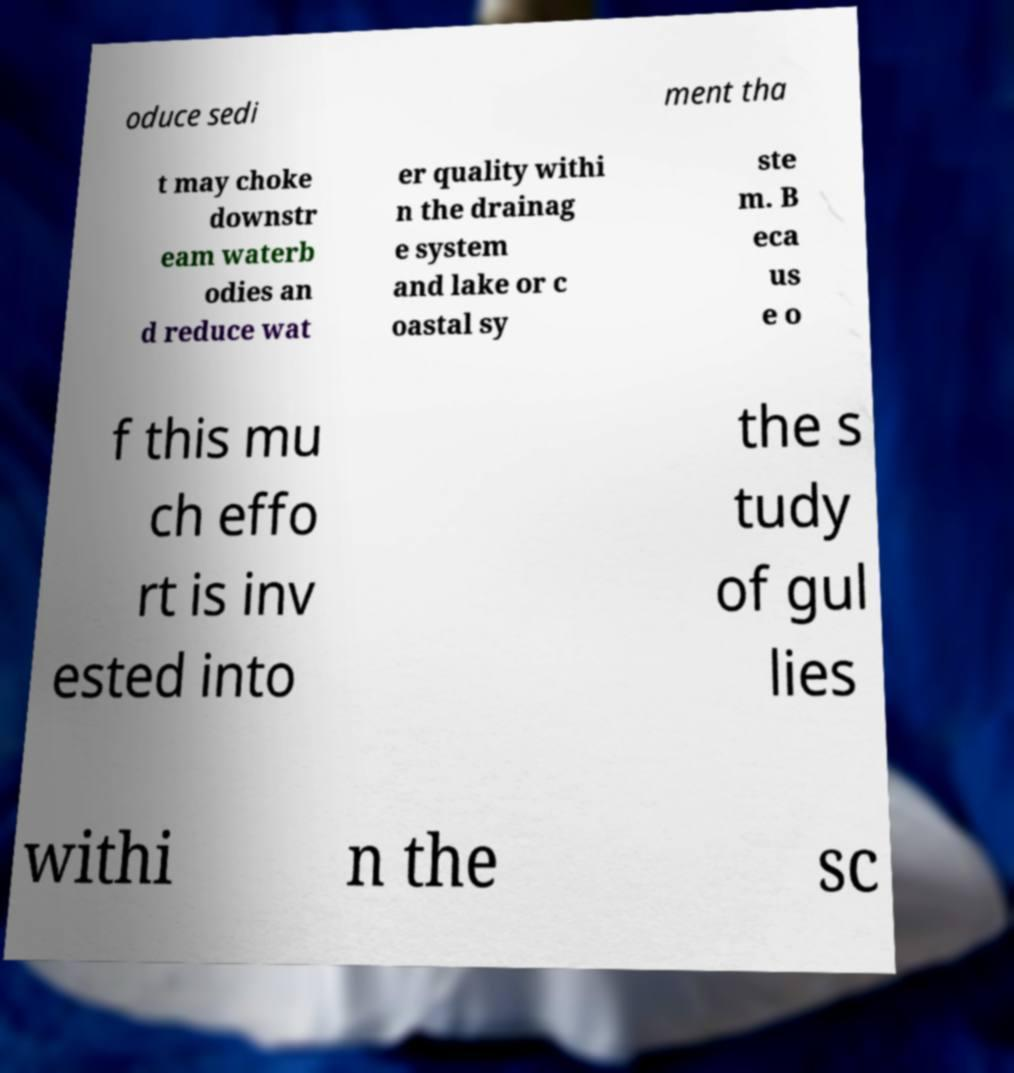Could you extract and type out the text from this image? oduce sedi ment tha t may choke downstr eam waterb odies an d reduce wat er quality withi n the drainag e system and lake or c oastal sy ste m. B eca us e o f this mu ch effo rt is inv ested into the s tudy of gul lies withi n the sc 